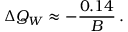Convert formula to latex. <formula><loc_0><loc_0><loc_500><loc_500>\Delta Q _ { W } \approx - { \frac { 0 . 1 4 } { B } } \, .</formula> 